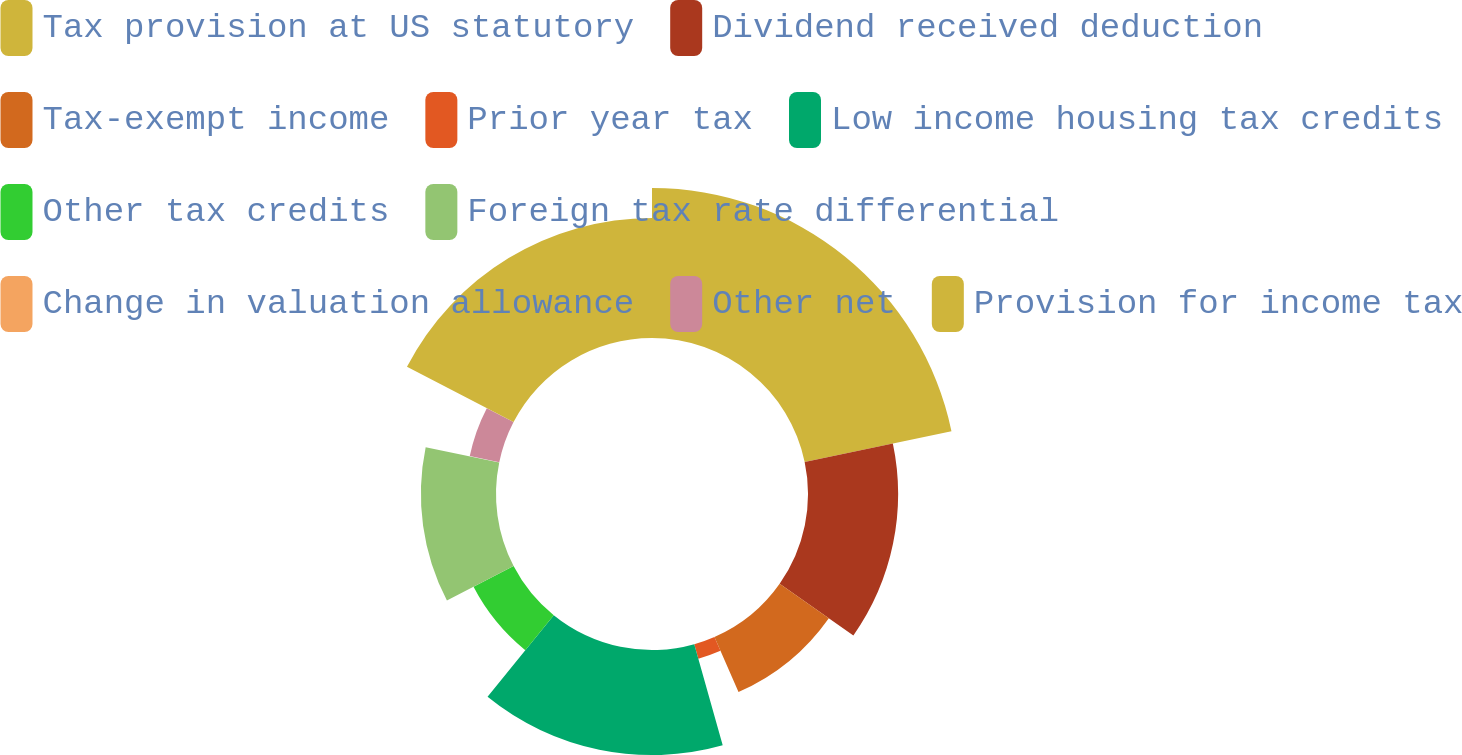Convert chart. <chart><loc_0><loc_0><loc_500><loc_500><pie_chart><fcel>Tax provision at US statutory<fcel>Dividend received deduction<fcel>Tax-exempt income<fcel>Prior year tax<fcel>Low income housing tax credits<fcel>Other tax credits<fcel>Foreign tax rate differential<fcel>Change in valuation allowance<fcel>Other net<fcel>Provision for income tax<nl><fcel>21.71%<fcel>13.04%<fcel>8.7%<fcel>2.19%<fcel>15.21%<fcel>6.53%<fcel>10.87%<fcel>0.02%<fcel>4.36%<fcel>17.38%<nl></chart> 